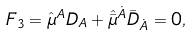Convert formula to latex. <formula><loc_0><loc_0><loc_500><loc_500>F _ { 3 } = \hat { \mu } ^ { A } D _ { A } + \hat { \bar { \mu } } ^ { \dot { A } } { \bar { D } } _ { \dot { A } } = 0 ,</formula> 